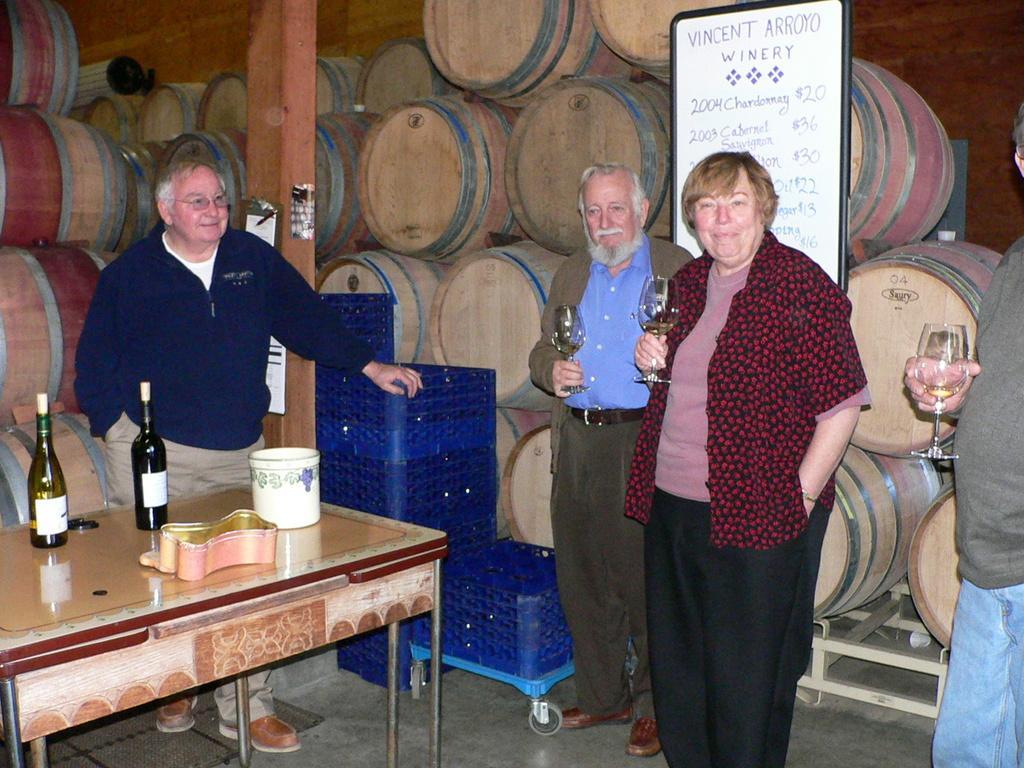Please provide a concise description of this image. In this image I can see people are standing among them these people are holding glasses in their hands. Here I can see table which has bottles and some other objects on it. In the background I can see barrels, a board which has something written on it and other objects on the floor. 